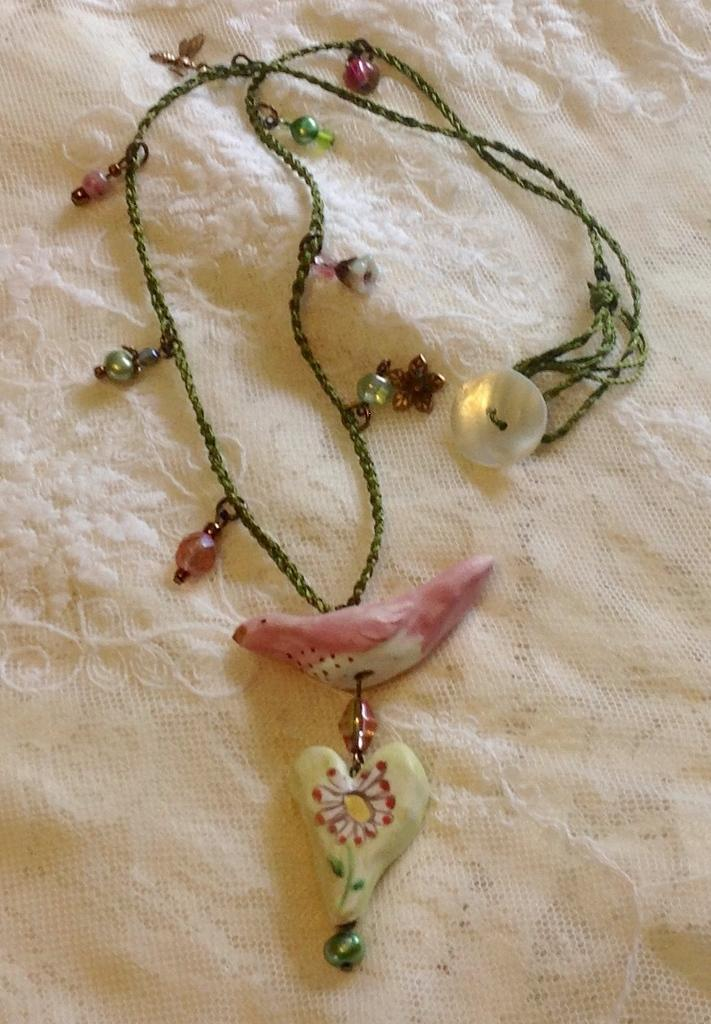What is the main object in the center of the image? There is a chain in the center of the image. What is attached to the chain? The chain contains a pendant. What is located at the bottom of the image? There is a cloth at the bottom of the image. What type of cap can be seen on the flesh of the person in the image? There is no person or cap present in the image; it only features a chain with a pendant and a cloth at the bottom. 